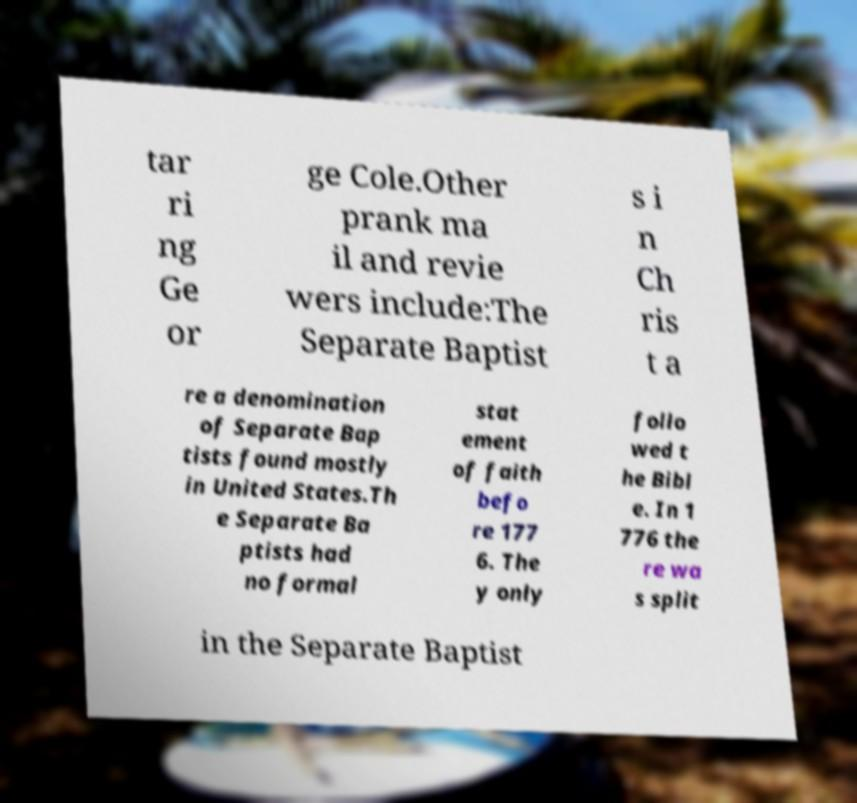For documentation purposes, I need the text within this image transcribed. Could you provide that? tar ri ng Ge or ge Cole.Other prank ma il and revie wers include:The Separate Baptist s i n Ch ris t a re a denomination of Separate Bap tists found mostly in United States.Th e Separate Ba ptists had no formal stat ement of faith befo re 177 6. The y only follo wed t he Bibl e. In 1 776 the re wa s split in the Separate Baptist 